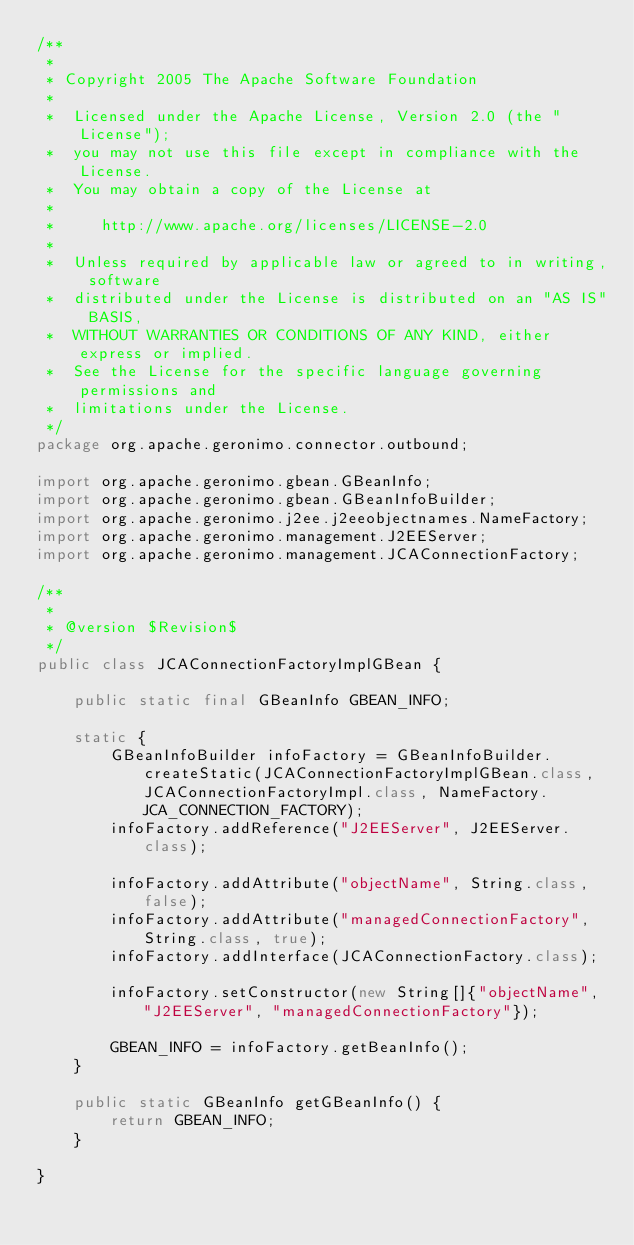Convert code to text. <code><loc_0><loc_0><loc_500><loc_500><_Java_>/**
 *
 * Copyright 2005 The Apache Software Foundation
 *
 *  Licensed under the Apache License, Version 2.0 (the "License");
 *  you may not use this file except in compliance with the License.
 *  You may obtain a copy of the License at
 *
 *     http://www.apache.org/licenses/LICENSE-2.0
 *
 *  Unless required by applicable law or agreed to in writing, software
 *  distributed under the License is distributed on an "AS IS" BASIS,
 *  WITHOUT WARRANTIES OR CONDITIONS OF ANY KIND, either express or implied.
 *  See the License for the specific language governing permissions and
 *  limitations under the License.
 */
package org.apache.geronimo.connector.outbound;

import org.apache.geronimo.gbean.GBeanInfo;
import org.apache.geronimo.gbean.GBeanInfoBuilder;
import org.apache.geronimo.j2ee.j2eeobjectnames.NameFactory;
import org.apache.geronimo.management.J2EEServer;
import org.apache.geronimo.management.JCAConnectionFactory;

/**
 * 
 * @version $Revision$
 */
public class JCAConnectionFactoryImplGBean {

    public static final GBeanInfo GBEAN_INFO;

    static {
        GBeanInfoBuilder infoFactory = GBeanInfoBuilder.createStatic(JCAConnectionFactoryImplGBean.class, JCAConnectionFactoryImpl.class, NameFactory.JCA_CONNECTION_FACTORY);
        infoFactory.addReference("J2EEServer", J2EEServer.class);

        infoFactory.addAttribute("objectName", String.class, false);
        infoFactory.addAttribute("managedConnectionFactory", String.class, true);
        infoFactory.addInterface(JCAConnectionFactory.class);

        infoFactory.setConstructor(new String[]{"objectName", "J2EEServer", "managedConnectionFactory"});

        GBEAN_INFO = infoFactory.getBeanInfo();
    }

    public static GBeanInfo getGBeanInfo() {
        return GBEAN_INFO;
    }

}
</code> 